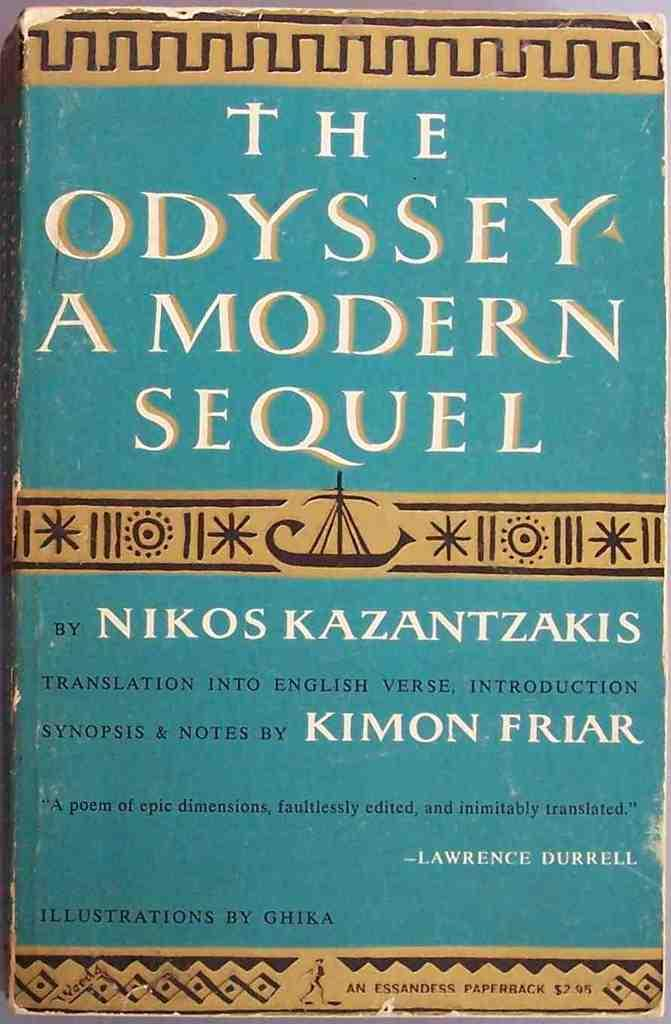Provide a one-sentence caption for the provided image. A book titled The Odyssey A Modern Sequel written by Nikos Kazantzakis. 